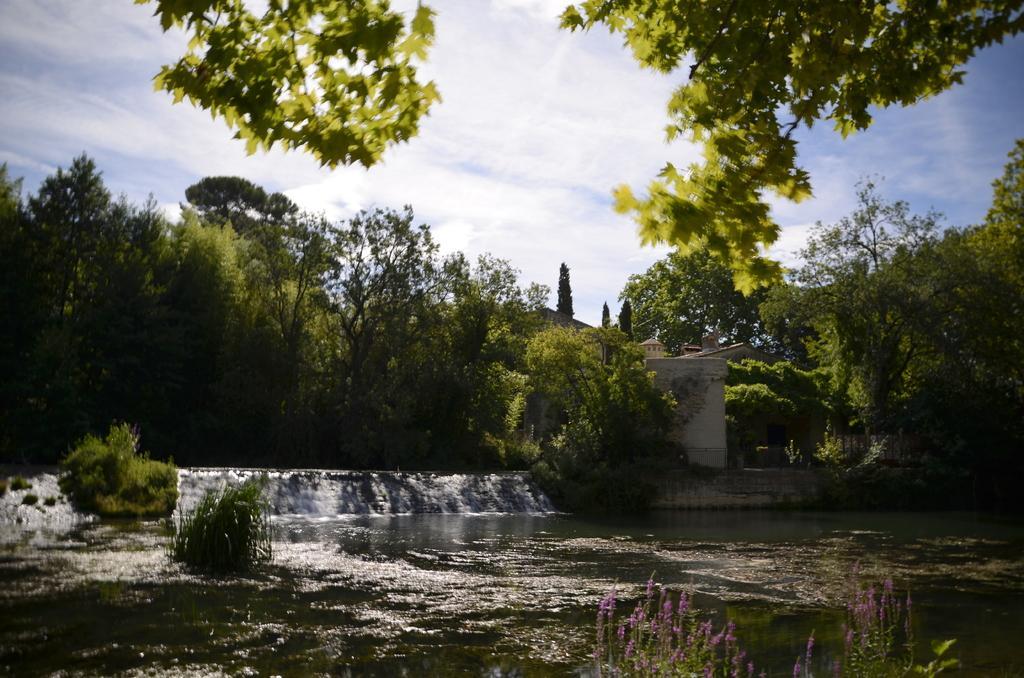How would you summarize this image in a sentence or two? In the picture I can see the water, plants, a building, trees some other objects. In the background I can see the sky. 